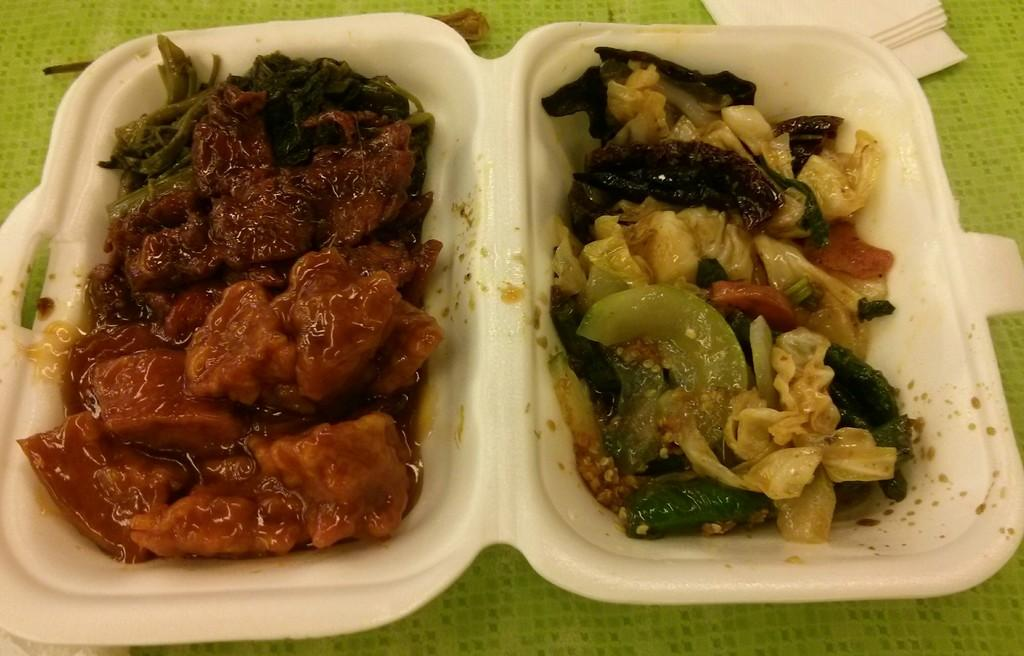What is the main object in the center of the image? There is a box in the center of the image. What is inside the box? The box contains food items. What type of brush is used to clean the food items in the box? There is no brush present in the image, and the food items are not being cleaned. 